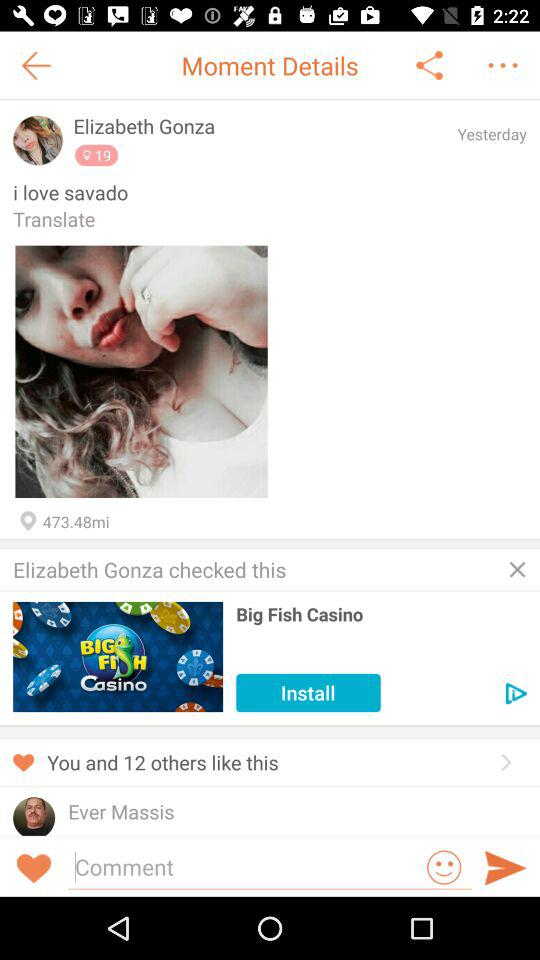When did Elizabeth post this post? Elizabeth posted this post yesterday. 